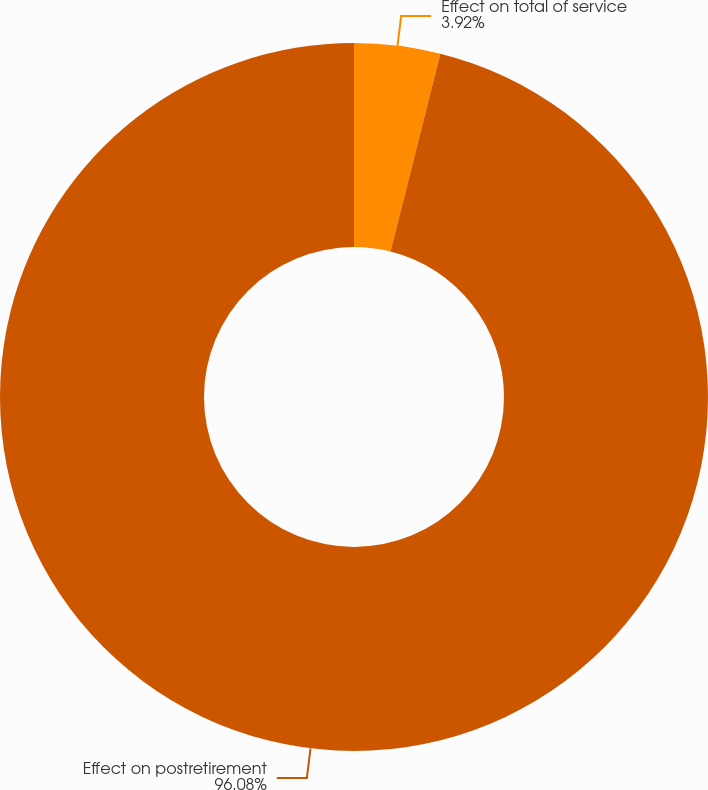<chart> <loc_0><loc_0><loc_500><loc_500><pie_chart><fcel>Effect on total of service<fcel>Effect on postretirement<nl><fcel>3.92%<fcel>96.08%<nl></chart> 